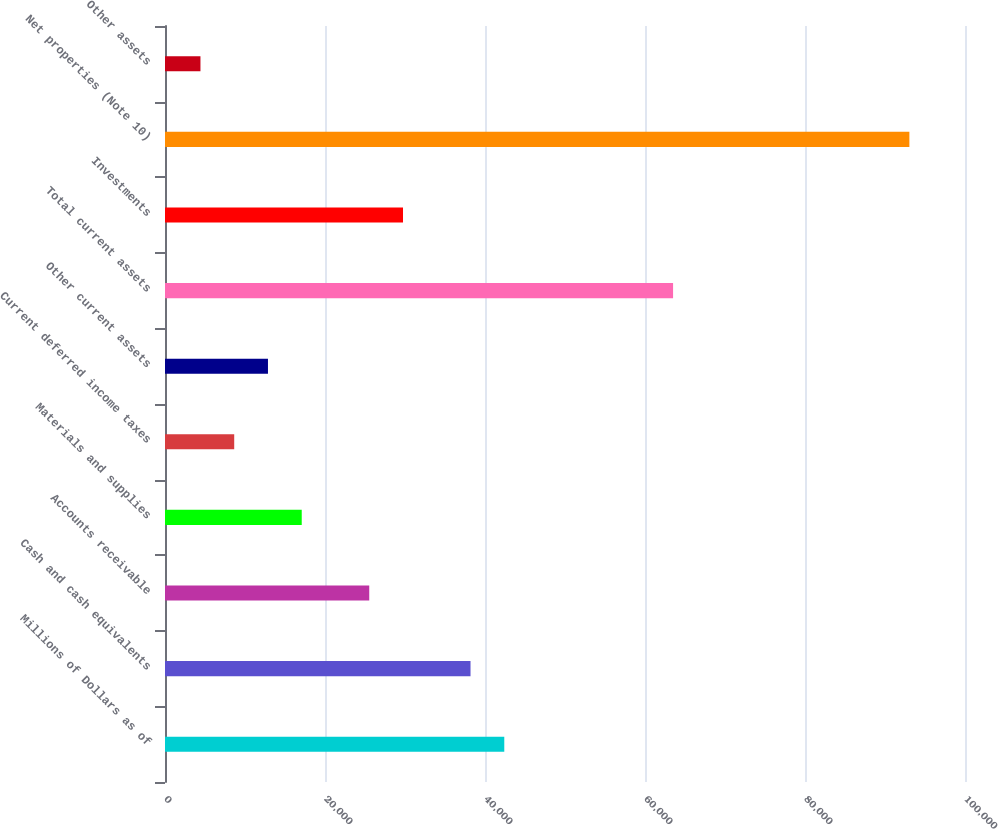<chart> <loc_0><loc_0><loc_500><loc_500><bar_chart><fcel>Millions of Dollars as of<fcel>Cash and cash equivalents<fcel>Accounts receivable<fcel>Materials and supplies<fcel>Current deferred income taxes<fcel>Other current assets<fcel>Total current assets<fcel>Investments<fcel>Net properties (Note 10)<fcel>Other assets<nl><fcel>42410<fcel>38190.2<fcel>25530.8<fcel>17091.2<fcel>8651.6<fcel>12871.4<fcel>63509<fcel>29750.6<fcel>93047.6<fcel>4431.8<nl></chart> 